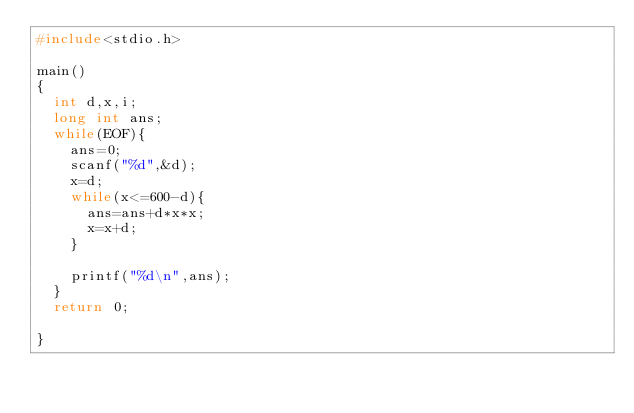Convert code to text. <code><loc_0><loc_0><loc_500><loc_500><_C_>#include<stdio.h>

main()
{
  int d,x,i;
  long int ans;
  while(EOF){
    ans=0;
    scanf("%d",&d);
    x=d;
    while(x<=600-d){
      ans=ans+d*x*x;
      x=x+d;
    }

    printf("%d\n",ans);
  }
  return 0;

}</code> 